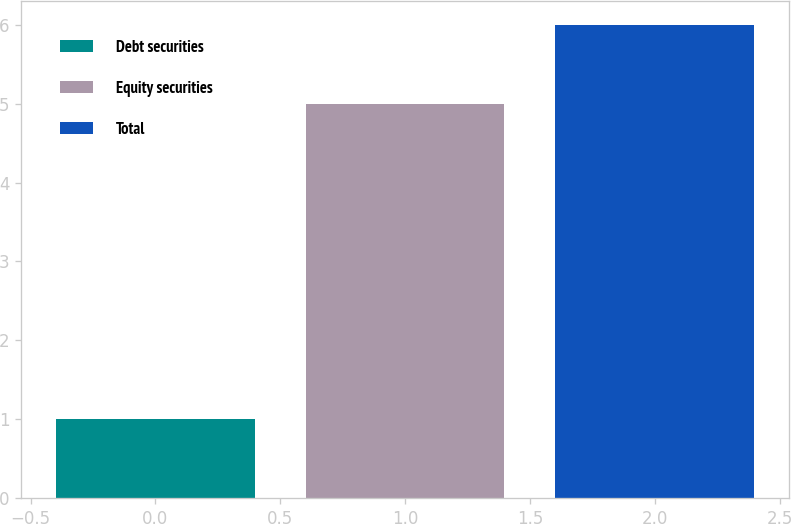<chart> <loc_0><loc_0><loc_500><loc_500><bar_chart><fcel>Debt securities<fcel>Equity securities<fcel>Total<nl><fcel>1<fcel>5<fcel>6<nl></chart> 